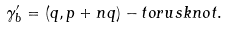Convert formula to latex. <formula><loc_0><loc_0><loc_500><loc_500>\gamma _ { b } ^ { \prime } = ( q , p + n q ) - t o r u s k n o t .</formula> 